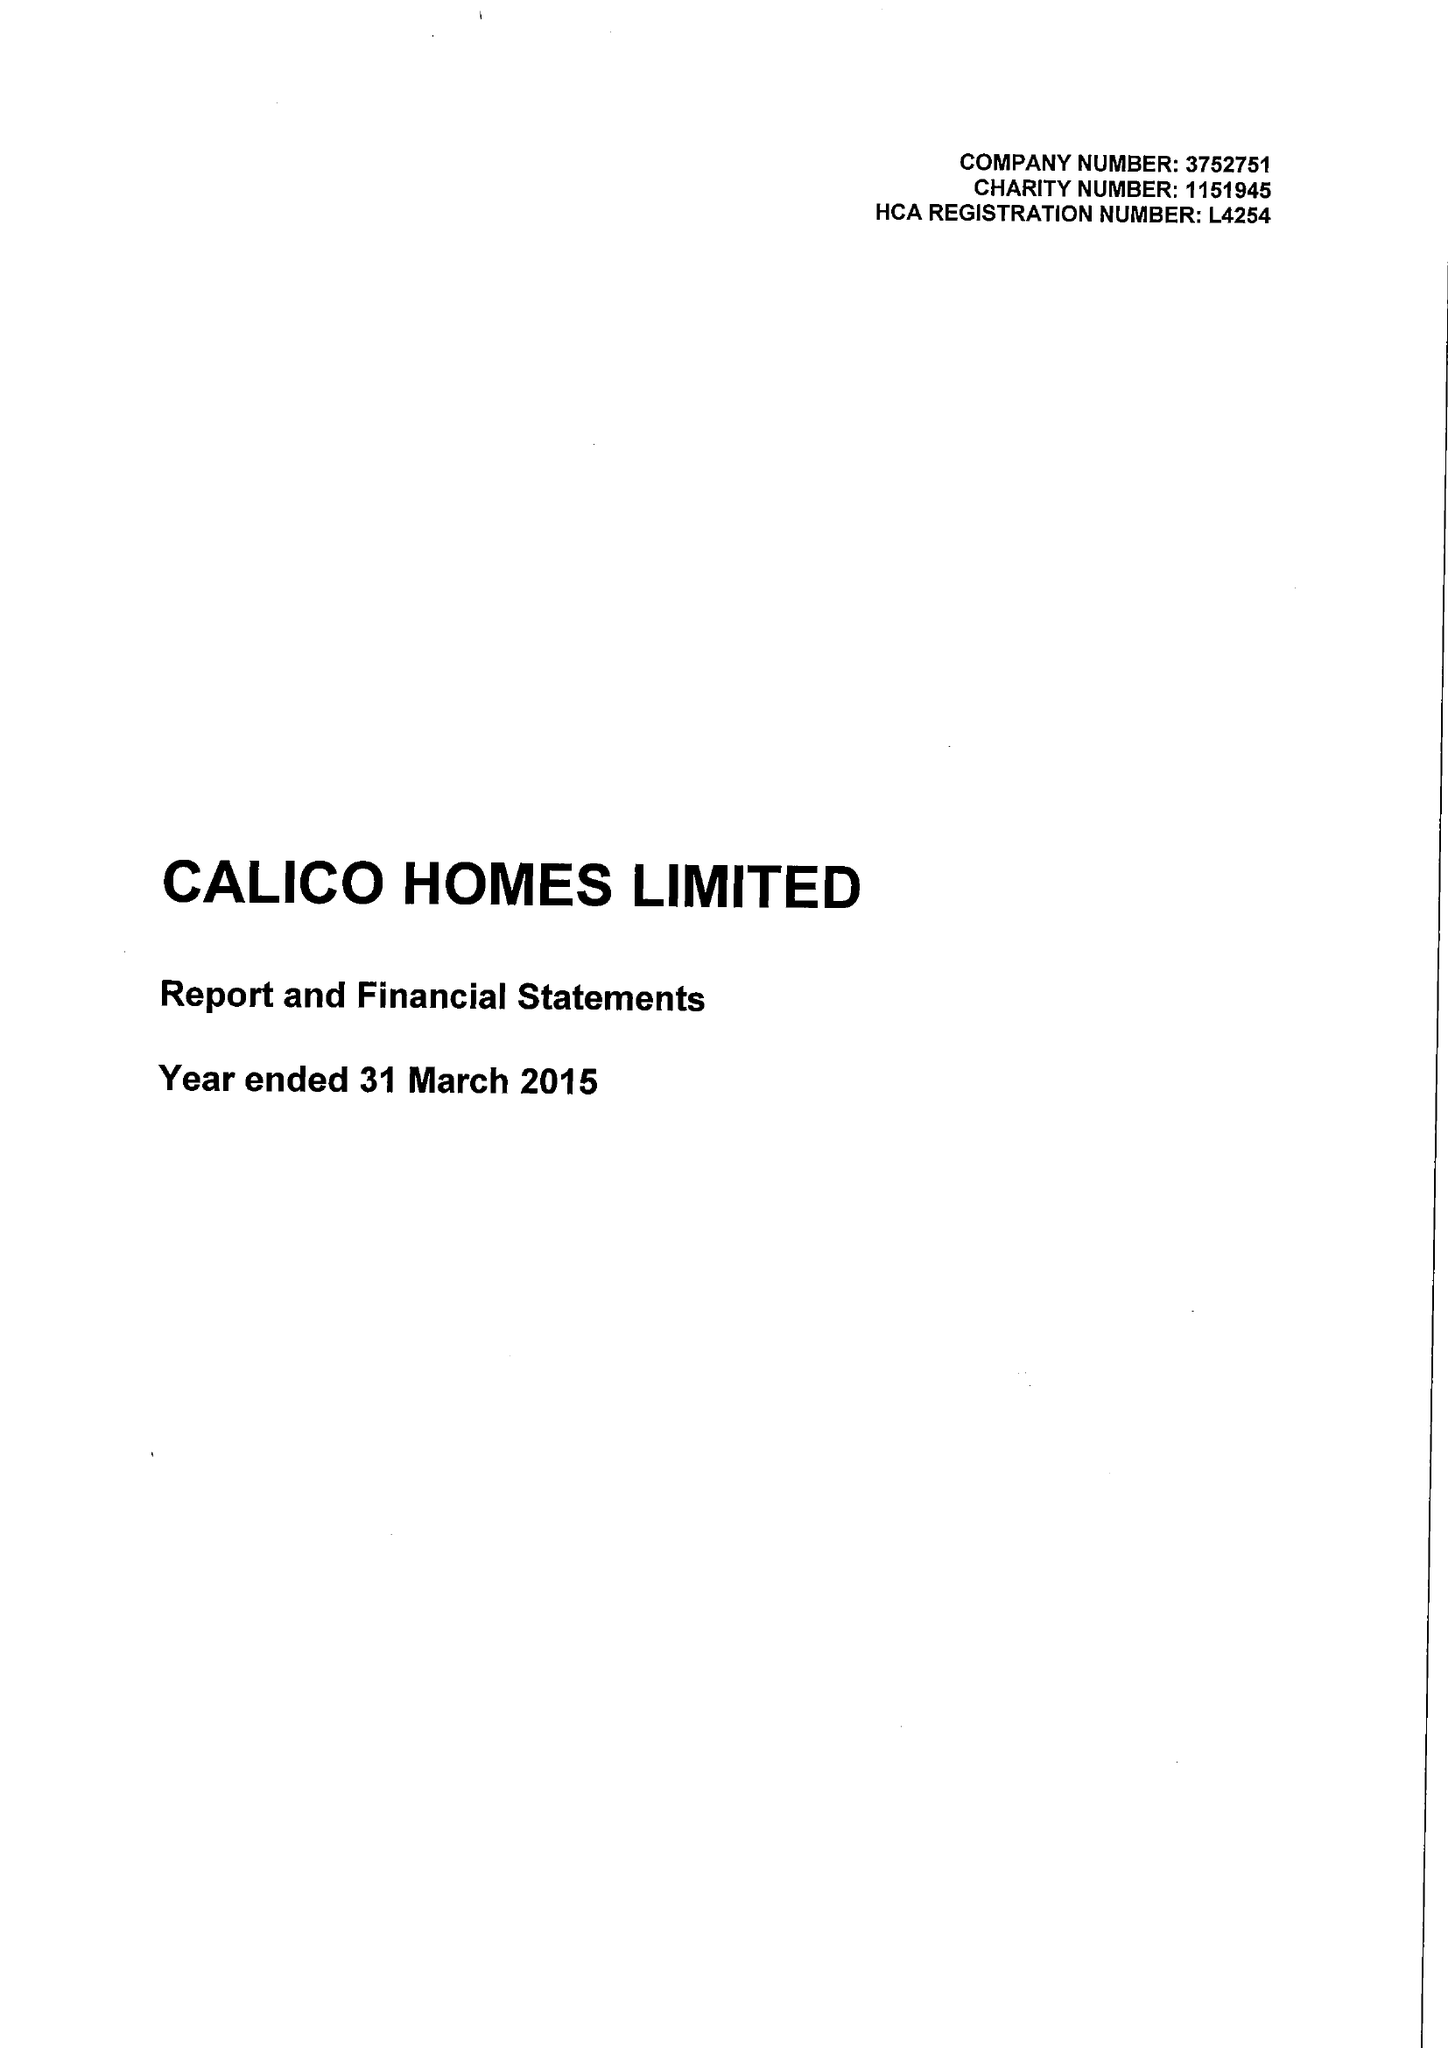What is the value for the income_annually_in_british_pounds?
Answer the question using a single word or phrase. 21232000.00 